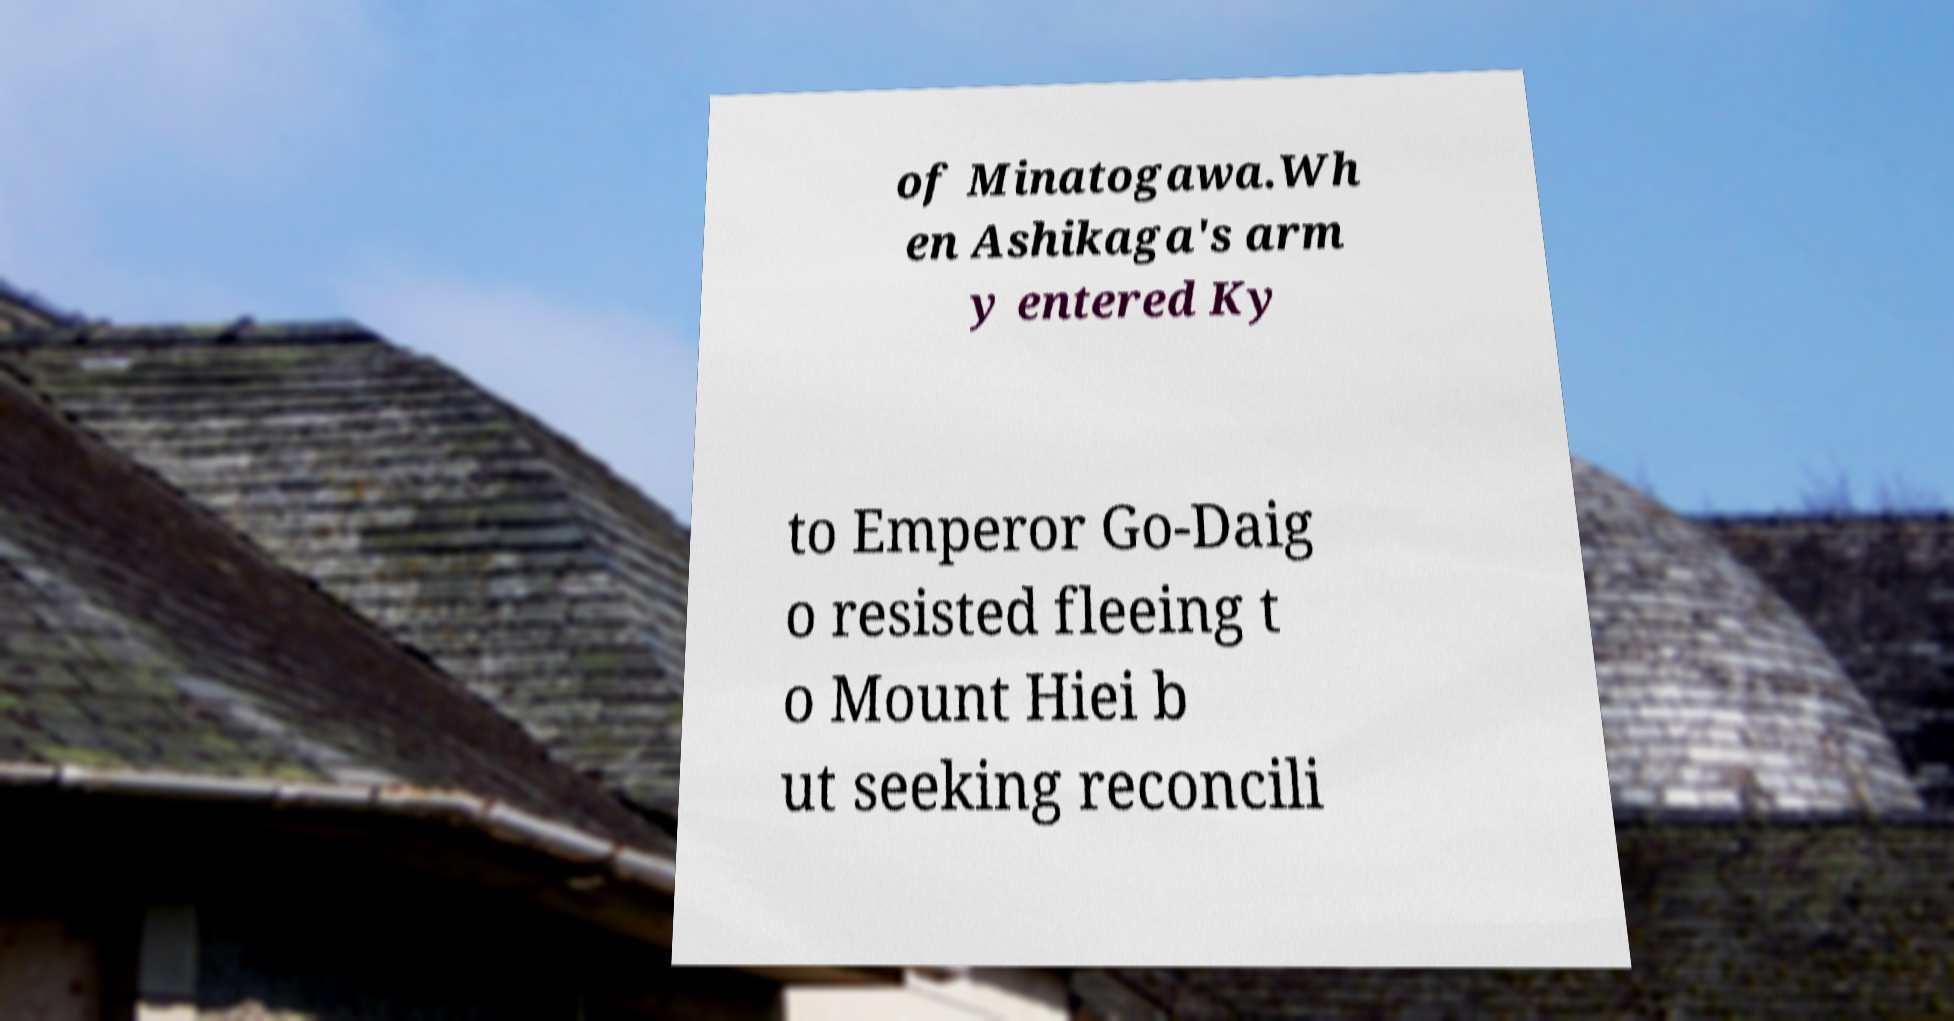I need the written content from this picture converted into text. Can you do that? of Minatogawa.Wh en Ashikaga's arm y entered Ky to Emperor Go-Daig o resisted fleeing t o Mount Hiei b ut seeking reconcili 